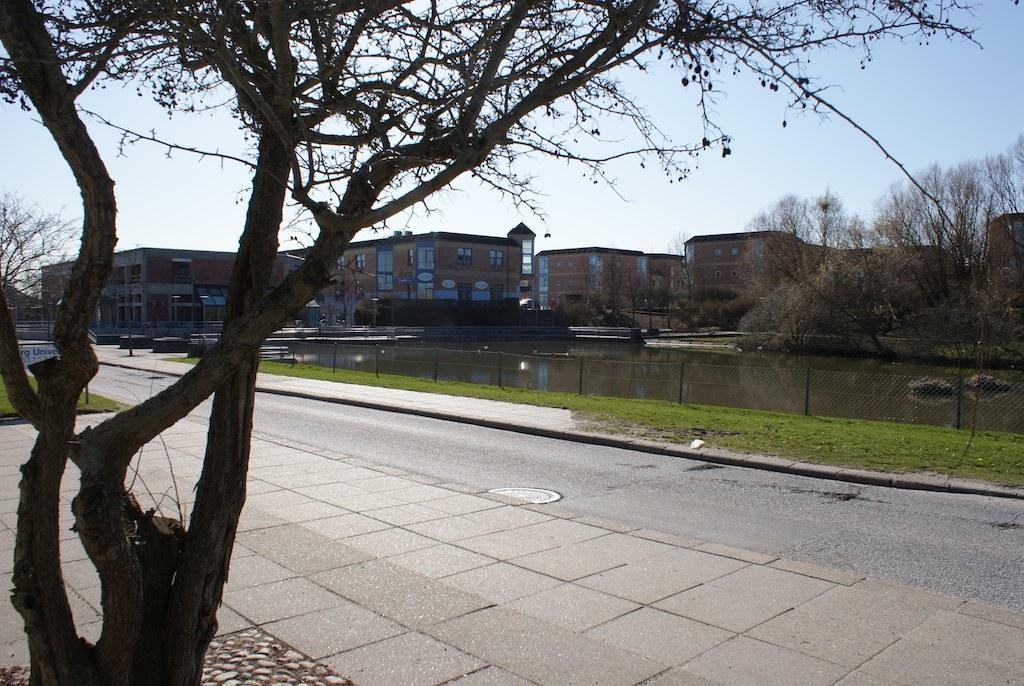Can you describe this image briefly? Here we can see trees, mesh, water, buildings and grass. To that buildings there are windows. Background there is a sky. 